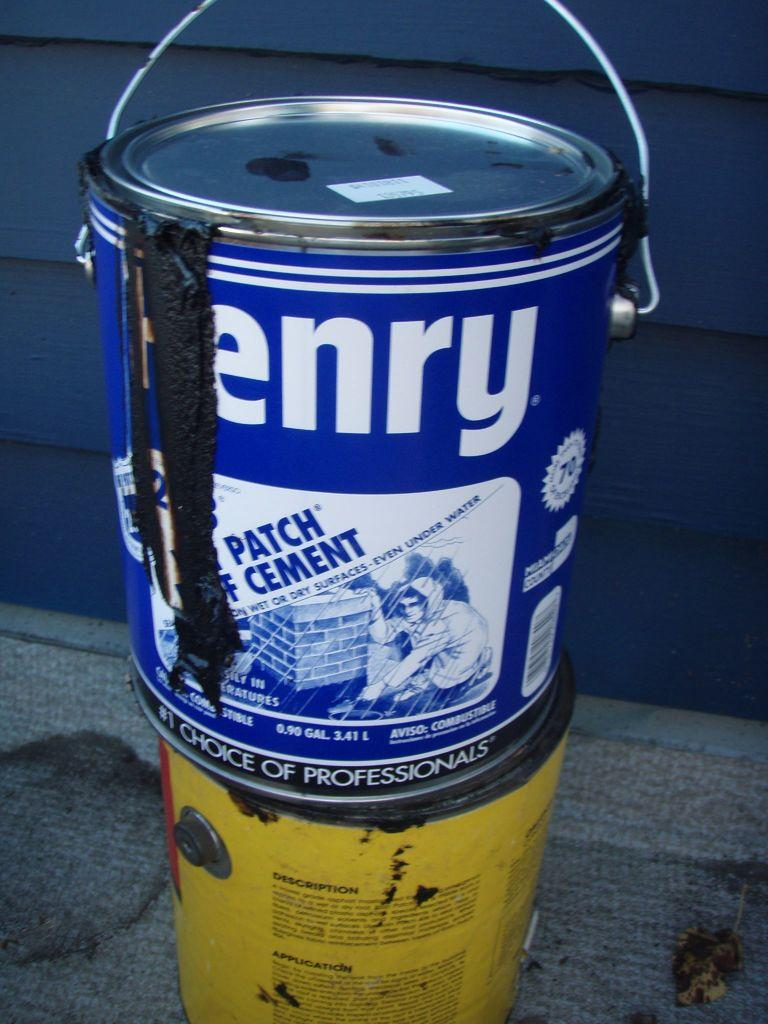<image>
Share a concise interpretation of the image provided. Two cans of something with the top can reading PATCH CEMENT. 